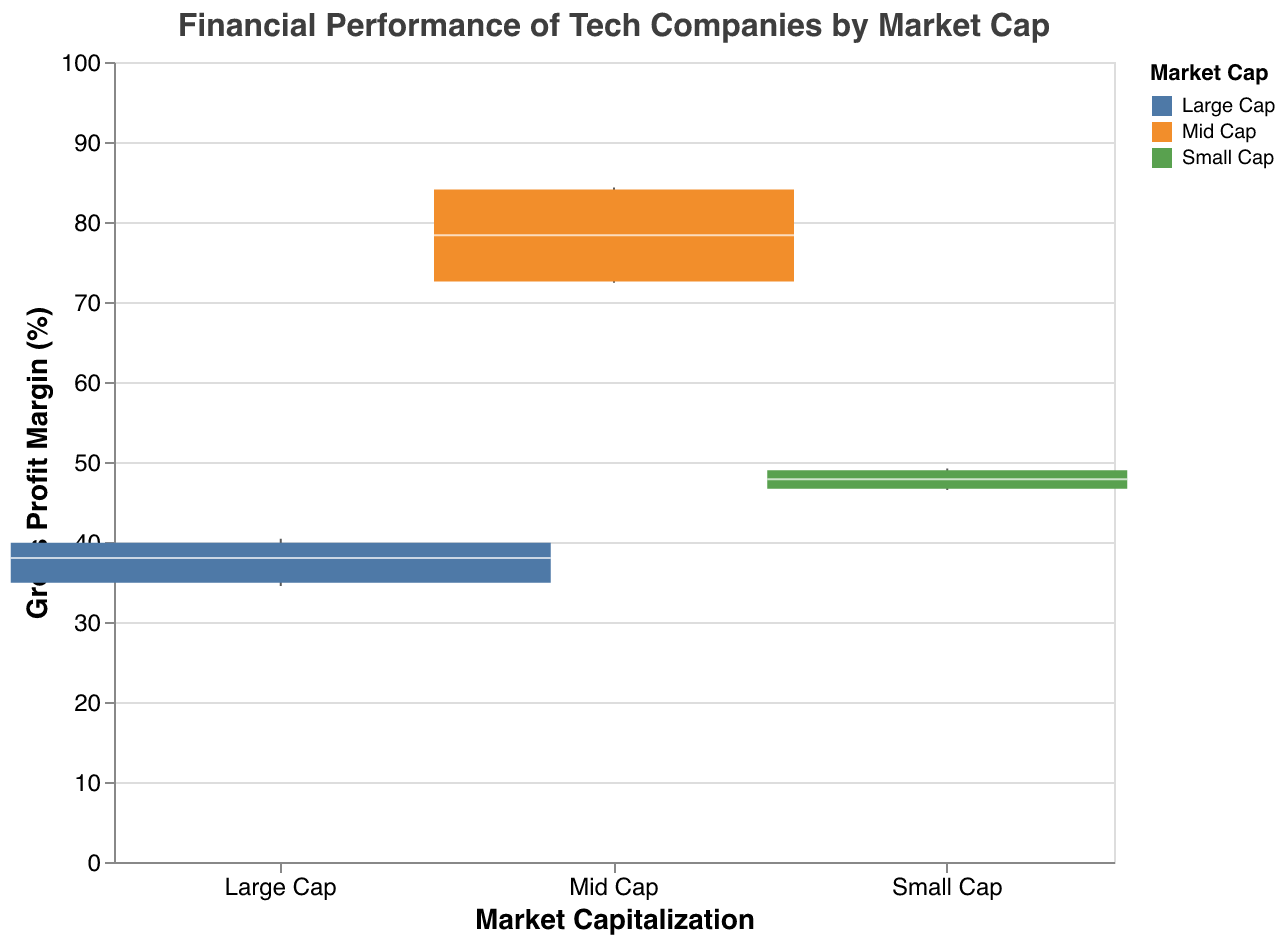What is the title of the figure? The title can be found at the top of the figure. It reads "Financial Performance of Tech Companies by Market Cap".
Answer: Financial Performance of Tech Companies by Market Cap What is the Gross Profit Margin (GPM) range for Large Cap companies? The range can be determined by the lower and upper whisker for the Large Cap category. These are approximately 34.5% and 40.4%.
Answer: 34.5% to 40.4% Which market capitalization group has the widest GPM interquartile range (IQR)? The IQR is the distance between the lower and upper bounds of the box. The largest box appears in the Mid Cap group.
Answer: Mid Cap What is the median GPM for Small Cap companies? The median is represented by the white tick mark within the box for Small Cap companies, approximately at 47.9%.
Answer: 47.9% Which market cap group shows the highest upper whisker value for GPM? The upper whisker represents the maximum GPM value within each group. The highest upper whisker is seen in the Mid Cap group, approximately at 84.3%.
Answer: Mid Cap Compare the Gross Profit Margin (GPM) medians of Large Cap and Mid Cap companies. Which is higher, and by how much? The medians are represented by the white tick marks within the boxes. Large Cap is around 38.1%, Mid Cap is around 78.0%. The difference is 40.9%.
Answer: Mid Cap, by 40.9% Is there any market cap group where the Gross Profit Margin (GPM) falls below 20%? By observing the lower whiskers for each group, only Small Cap and Large Cap show whiskers above 20%. Hence, there’s no group where the GPM falls below 20%.
Answer: No What is the interquartile range (IQR) for the Mid Cap companies' GPM? The IQR is the difference between the upper bound and lower bound of the box. The Mid Cap has bounds approximately at 31.3% and 84.1%, giving an IQR of about 52.8%.
Answer: 52.8% Which group has the most companies sampled based on the box width? The box width is proportional to the sample size. The widest box appears in the Small Cap group.
Answer: Small Cap Which market cap group has the most consistent GPM values (smallest IQR)? Consistency is represented by the smallest interquartile range (IQR). The Large Cap group has the smallest IQR, indicating the most consistent GPM values.
Answer: Large Cap 